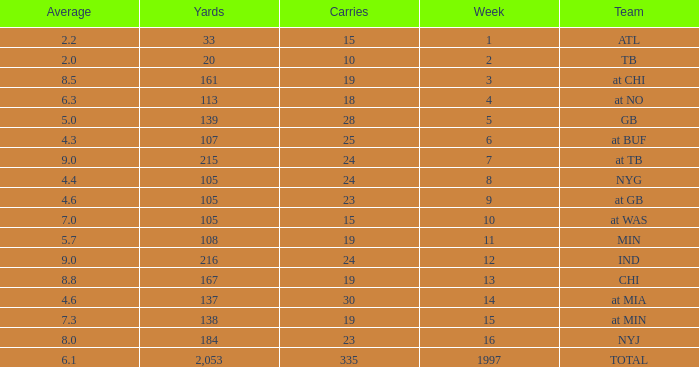Which Yards have Carries smaller than 23, and a Team of at chi, and an Average smaller than 8.5? None. 